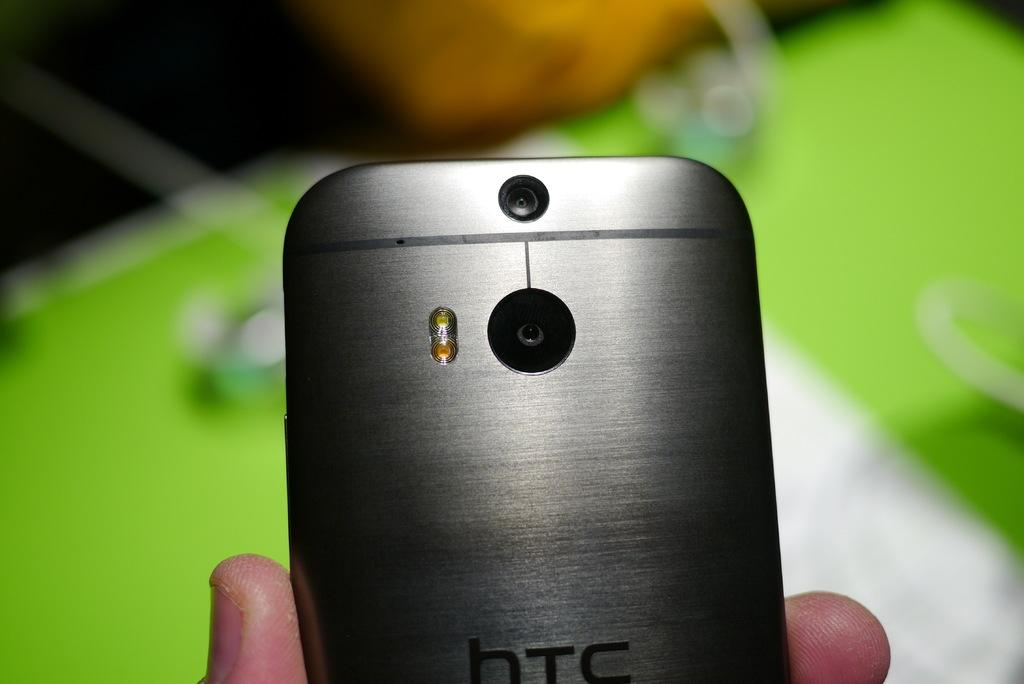<image>
Render a clear and concise summary of the photo. Silver htc phone with a black camera on the back. 